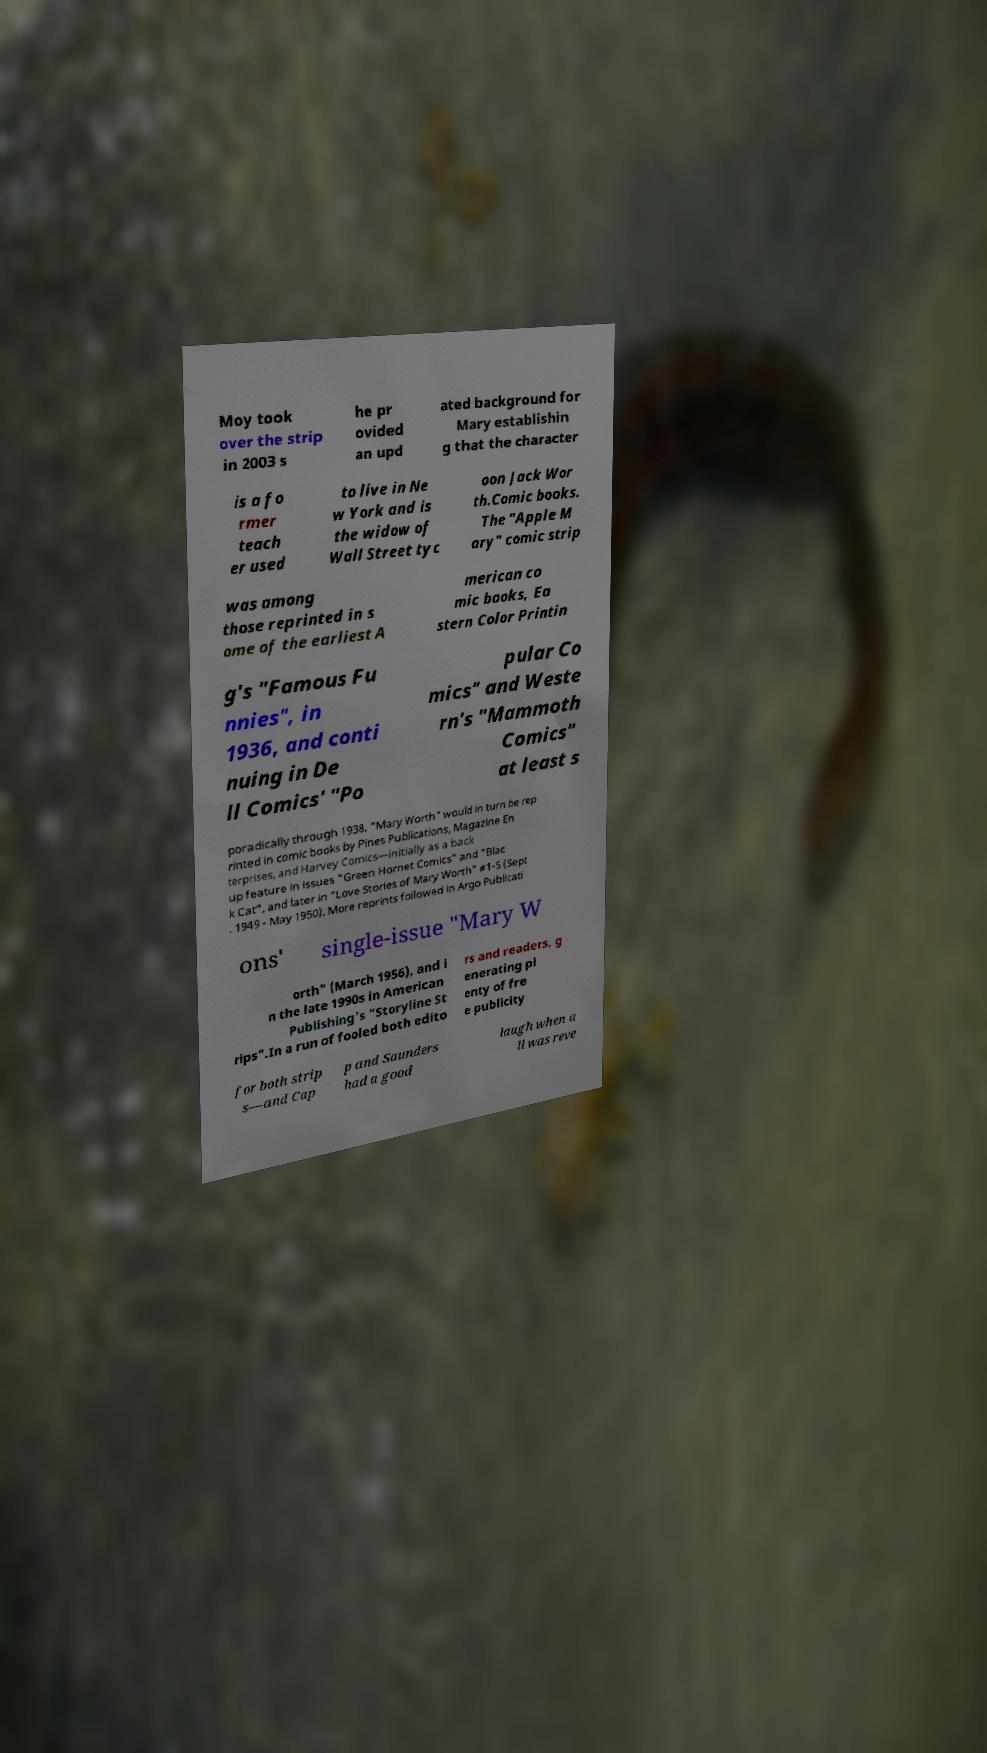For documentation purposes, I need the text within this image transcribed. Could you provide that? Moy took over the strip in 2003 s he pr ovided an upd ated background for Mary establishin g that the character is a fo rmer teach er used to live in Ne w York and is the widow of Wall Street tyc oon Jack Wor th.Comic books. The "Apple M ary" comic strip was among those reprinted in s ome of the earliest A merican co mic books, Ea stern Color Printin g's "Famous Fu nnies", in 1936, and conti nuing in De ll Comics' "Po pular Co mics" and Weste rn's "Mammoth Comics" at least s poradically through 1938. "Mary Worth" would in turn be rep rinted in comic books by Pines Publications, Magazine En terprises, and Harvey Comics—initially as a back up feature in issues "Green Hornet Comics" and "Blac k Cat", and later in "Love Stories of Mary Worth" #1-5 (Sept . 1949 - May 1950). More reprints followed in Argo Publicati ons' single-issue "Mary W orth" (March 1956), and i n the late 1990s in American Publishing's "Storyline St rips".In a run of fooled both edito rs and readers, g enerating pl enty of fre e publicity for both strip s—and Cap p and Saunders had a good laugh when a ll was reve 